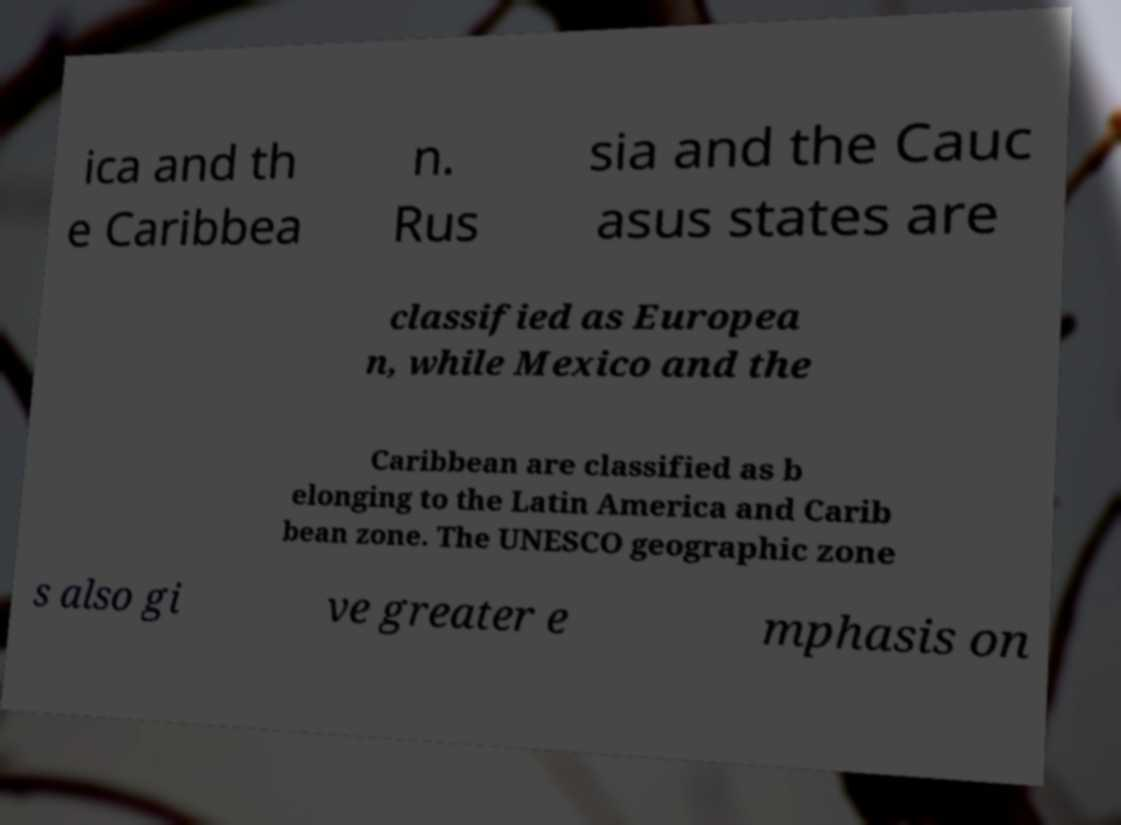I need the written content from this picture converted into text. Can you do that? ica and th e Caribbea n. Rus sia and the Cauc asus states are classified as Europea n, while Mexico and the Caribbean are classified as b elonging to the Latin America and Carib bean zone. The UNESCO geographic zone s also gi ve greater e mphasis on 